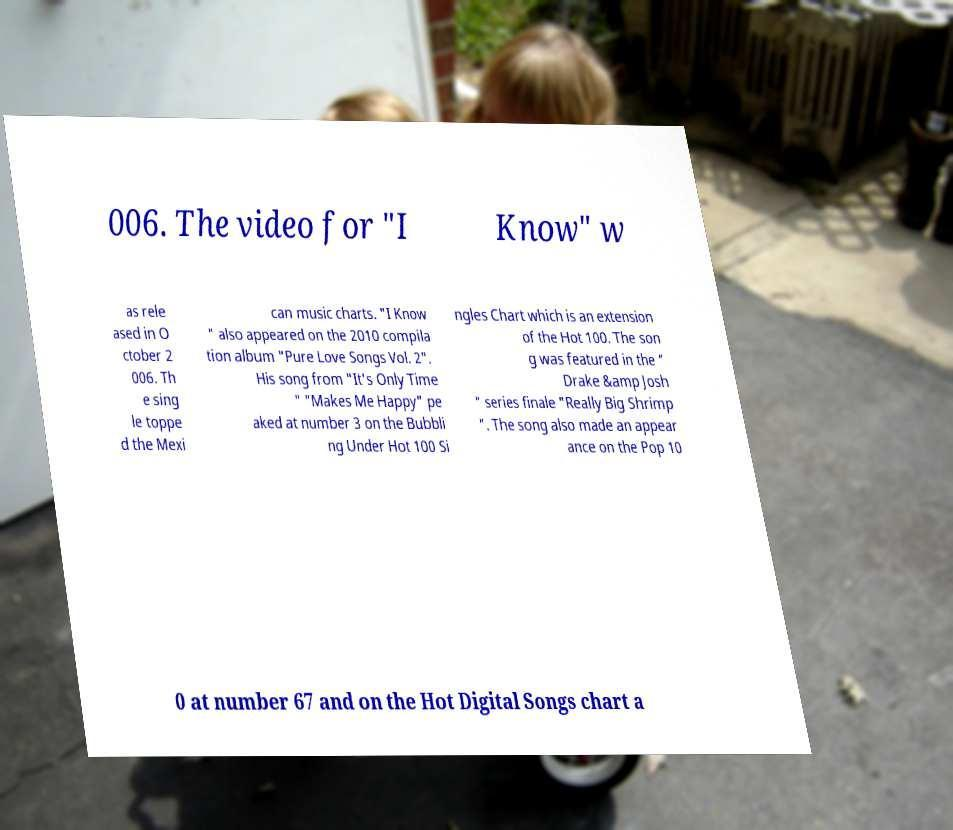There's text embedded in this image that I need extracted. Can you transcribe it verbatim? 006. The video for "I Know" w as rele ased in O ctober 2 006. Th e sing le toppe d the Mexi can music charts. "I Know " also appeared on the 2010 compila tion album "Pure Love Songs Vol. 2". His song from "It's Only Time " "Makes Me Happy" pe aked at number 3 on the Bubbli ng Under Hot 100 Si ngles Chart which is an extension of the Hot 100. The son g was featured in the " Drake &amp Josh " series finale "Really Big Shrimp ". The song also made an appear ance on the Pop 10 0 at number 67 and on the Hot Digital Songs chart a 